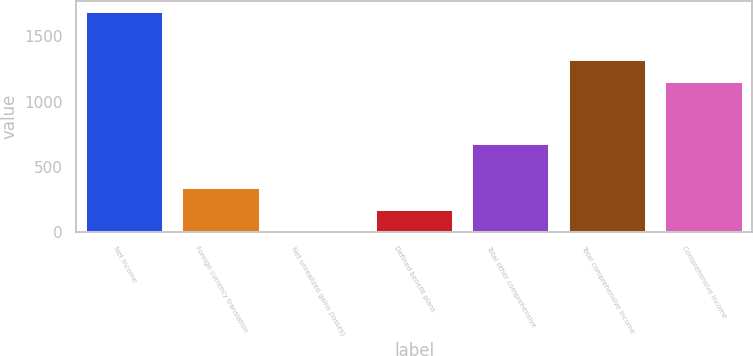<chart> <loc_0><loc_0><loc_500><loc_500><bar_chart><fcel>Net income<fcel>Foreign currency translation<fcel>Net unrealized gains (losses)<fcel>Defined benefit plans<fcel>Total other comprehensive<fcel>Total comprehensive income<fcel>Comprehensive income<nl><fcel>1687<fcel>338.2<fcel>1<fcel>169.6<fcel>675.4<fcel>1321.6<fcel>1153<nl></chart> 